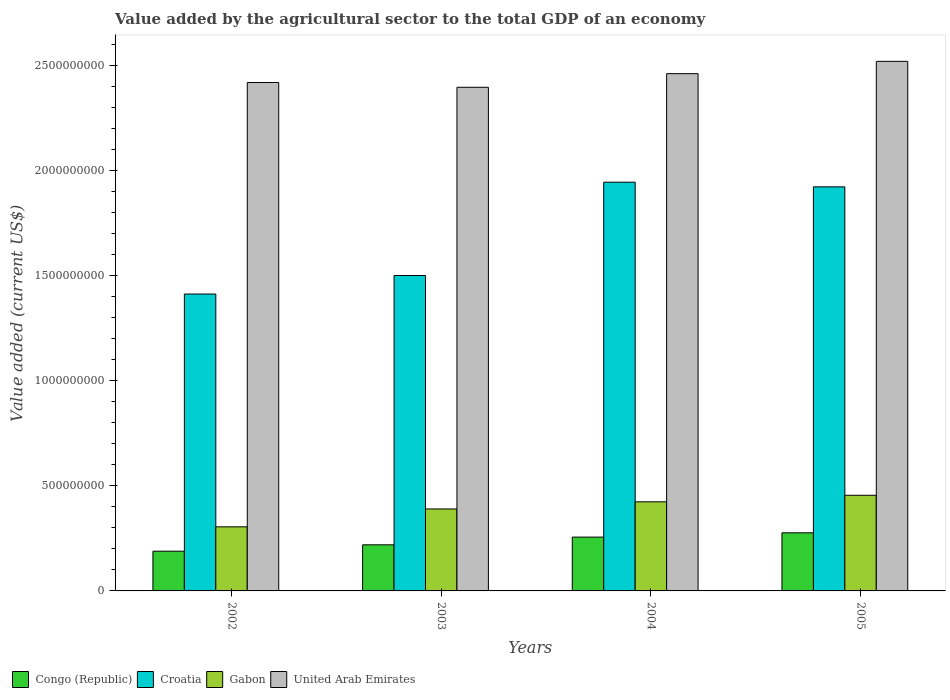Are the number of bars on each tick of the X-axis equal?
Provide a short and direct response. Yes. How many bars are there on the 3rd tick from the left?
Provide a succinct answer. 4. How many bars are there on the 1st tick from the right?
Make the answer very short. 4. What is the label of the 3rd group of bars from the left?
Ensure brevity in your answer.  2004. What is the value added by the agricultural sector to the total GDP in Croatia in 2003?
Provide a short and direct response. 1.50e+09. Across all years, what is the maximum value added by the agricultural sector to the total GDP in Croatia?
Provide a succinct answer. 1.95e+09. Across all years, what is the minimum value added by the agricultural sector to the total GDP in Croatia?
Offer a terse response. 1.41e+09. What is the total value added by the agricultural sector to the total GDP in Congo (Republic) in the graph?
Give a very brief answer. 9.41e+08. What is the difference between the value added by the agricultural sector to the total GDP in Congo (Republic) in 2002 and that in 2004?
Offer a very short reply. -6.70e+07. What is the difference between the value added by the agricultural sector to the total GDP in Congo (Republic) in 2003 and the value added by the agricultural sector to the total GDP in Croatia in 2002?
Provide a succinct answer. -1.19e+09. What is the average value added by the agricultural sector to the total GDP in United Arab Emirates per year?
Provide a short and direct response. 2.45e+09. In the year 2002, what is the difference between the value added by the agricultural sector to the total GDP in United Arab Emirates and value added by the agricultural sector to the total GDP in Gabon?
Your response must be concise. 2.11e+09. In how many years, is the value added by the agricultural sector to the total GDP in United Arab Emirates greater than 1300000000 US$?
Provide a short and direct response. 4. What is the ratio of the value added by the agricultural sector to the total GDP in Congo (Republic) in 2003 to that in 2005?
Your answer should be compact. 0.79. Is the value added by the agricultural sector to the total GDP in United Arab Emirates in 2002 less than that in 2004?
Provide a succinct answer. Yes. What is the difference between the highest and the second highest value added by the agricultural sector to the total GDP in Gabon?
Provide a succinct answer. 3.11e+07. What is the difference between the highest and the lowest value added by the agricultural sector to the total GDP in Gabon?
Provide a succinct answer. 1.50e+08. In how many years, is the value added by the agricultural sector to the total GDP in United Arab Emirates greater than the average value added by the agricultural sector to the total GDP in United Arab Emirates taken over all years?
Give a very brief answer. 2. What does the 2nd bar from the left in 2005 represents?
Give a very brief answer. Croatia. What does the 3rd bar from the right in 2004 represents?
Keep it short and to the point. Croatia. Are all the bars in the graph horizontal?
Offer a terse response. No. What is the difference between two consecutive major ticks on the Y-axis?
Your answer should be very brief. 5.00e+08. Does the graph contain any zero values?
Provide a succinct answer. No. How many legend labels are there?
Give a very brief answer. 4. What is the title of the graph?
Offer a terse response. Value added by the agricultural sector to the total GDP of an economy. Does "Palau" appear as one of the legend labels in the graph?
Offer a very short reply. No. What is the label or title of the Y-axis?
Provide a succinct answer. Value added (current US$). What is the Value added (current US$) in Congo (Republic) in 2002?
Ensure brevity in your answer.  1.89e+08. What is the Value added (current US$) of Croatia in 2002?
Make the answer very short. 1.41e+09. What is the Value added (current US$) of Gabon in 2002?
Your answer should be compact. 3.05e+08. What is the Value added (current US$) of United Arab Emirates in 2002?
Your answer should be compact. 2.42e+09. What is the Value added (current US$) in Congo (Republic) in 2003?
Your answer should be compact. 2.19e+08. What is the Value added (current US$) in Croatia in 2003?
Make the answer very short. 1.50e+09. What is the Value added (current US$) of Gabon in 2003?
Your answer should be very brief. 3.90e+08. What is the Value added (current US$) in United Arab Emirates in 2003?
Provide a succinct answer. 2.40e+09. What is the Value added (current US$) in Congo (Republic) in 2004?
Your answer should be very brief. 2.56e+08. What is the Value added (current US$) of Croatia in 2004?
Give a very brief answer. 1.95e+09. What is the Value added (current US$) in Gabon in 2004?
Offer a terse response. 4.24e+08. What is the Value added (current US$) in United Arab Emirates in 2004?
Provide a short and direct response. 2.46e+09. What is the Value added (current US$) of Congo (Republic) in 2005?
Offer a terse response. 2.77e+08. What is the Value added (current US$) in Croatia in 2005?
Your response must be concise. 1.92e+09. What is the Value added (current US$) in Gabon in 2005?
Your response must be concise. 4.55e+08. What is the Value added (current US$) of United Arab Emirates in 2005?
Offer a terse response. 2.52e+09. Across all years, what is the maximum Value added (current US$) in Congo (Republic)?
Ensure brevity in your answer.  2.77e+08. Across all years, what is the maximum Value added (current US$) in Croatia?
Make the answer very short. 1.95e+09. Across all years, what is the maximum Value added (current US$) of Gabon?
Offer a terse response. 4.55e+08. Across all years, what is the maximum Value added (current US$) of United Arab Emirates?
Your response must be concise. 2.52e+09. Across all years, what is the minimum Value added (current US$) in Congo (Republic)?
Your answer should be very brief. 1.89e+08. Across all years, what is the minimum Value added (current US$) in Croatia?
Offer a terse response. 1.41e+09. Across all years, what is the minimum Value added (current US$) of Gabon?
Give a very brief answer. 3.05e+08. Across all years, what is the minimum Value added (current US$) of United Arab Emirates?
Offer a terse response. 2.40e+09. What is the total Value added (current US$) in Congo (Republic) in the graph?
Provide a succinct answer. 9.41e+08. What is the total Value added (current US$) of Croatia in the graph?
Provide a short and direct response. 6.78e+09. What is the total Value added (current US$) of Gabon in the graph?
Ensure brevity in your answer.  1.57e+09. What is the total Value added (current US$) of United Arab Emirates in the graph?
Keep it short and to the point. 9.80e+09. What is the difference between the Value added (current US$) of Congo (Republic) in 2002 and that in 2003?
Offer a very short reply. -3.03e+07. What is the difference between the Value added (current US$) in Croatia in 2002 and that in 2003?
Your answer should be compact. -8.82e+07. What is the difference between the Value added (current US$) in Gabon in 2002 and that in 2003?
Offer a very short reply. -8.51e+07. What is the difference between the Value added (current US$) in United Arab Emirates in 2002 and that in 2003?
Make the answer very short. 2.26e+07. What is the difference between the Value added (current US$) in Congo (Republic) in 2002 and that in 2004?
Make the answer very short. -6.70e+07. What is the difference between the Value added (current US$) of Croatia in 2002 and that in 2004?
Your response must be concise. -5.32e+08. What is the difference between the Value added (current US$) in Gabon in 2002 and that in 2004?
Provide a succinct answer. -1.19e+08. What is the difference between the Value added (current US$) in United Arab Emirates in 2002 and that in 2004?
Offer a terse response. -4.22e+07. What is the difference between the Value added (current US$) of Congo (Republic) in 2002 and that in 2005?
Make the answer very short. -8.75e+07. What is the difference between the Value added (current US$) in Croatia in 2002 and that in 2005?
Your answer should be very brief. -5.10e+08. What is the difference between the Value added (current US$) in Gabon in 2002 and that in 2005?
Offer a very short reply. -1.50e+08. What is the difference between the Value added (current US$) of United Arab Emirates in 2002 and that in 2005?
Keep it short and to the point. -1.01e+08. What is the difference between the Value added (current US$) in Congo (Republic) in 2003 and that in 2004?
Ensure brevity in your answer.  -3.67e+07. What is the difference between the Value added (current US$) of Croatia in 2003 and that in 2004?
Keep it short and to the point. -4.44e+08. What is the difference between the Value added (current US$) of Gabon in 2003 and that in 2004?
Give a very brief answer. -3.40e+07. What is the difference between the Value added (current US$) in United Arab Emirates in 2003 and that in 2004?
Your response must be concise. -6.48e+07. What is the difference between the Value added (current US$) of Congo (Republic) in 2003 and that in 2005?
Your answer should be very brief. -5.72e+07. What is the difference between the Value added (current US$) in Croatia in 2003 and that in 2005?
Make the answer very short. -4.22e+08. What is the difference between the Value added (current US$) of Gabon in 2003 and that in 2005?
Your answer should be compact. -6.51e+07. What is the difference between the Value added (current US$) in United Arab Emirates in 2003 and that in 2005?
Provide a succinct answer. -1.23e+08. What is the difference between the Value added (current US$) in Congo (Republic) in 2004 and that in 2005?
Provide a short and direct response. -2.05e+07. What is the difference between the Value added (current US$) of Croatia in 2004 and that in 2005?
Offer a very short reply. 2.22e+07. What is the difference between the Value added (current US$) in Gabon in 2004 and that in 2005?
Provide a succinct answer. -3.11e+07. What is the difference between the Value added (current US$) in United Arab Emirates in 2004 and that in 2005?
Keep it short and to the point. -5.85e+07. What is the difference between the Value added (current US$) in Congo (Republic) in 2002 and the Value added (current US$) in Croatia in 2003?
Offer a terse response. -1.31e+09. What is the difference between the Value added (current US$) of Congo (Republic) in 2002 and the Value added (current US$) of Gabon in 2003?
Your answer should be very brief. -2.01e+08. What is the difference between the Value added (current US$) in Congo (Republic) in 2002 and the Value added (current US$) in United Arab Emirates in 2003?
Your response must be concise. -2.21e+09. What is the difference between the Value added (current US$) of Croatia in 2002 and the Value added (current US$) of Gabon in 2003?
Offer a terse response. 1.02e+09. What is the difference between the Value added (current US$) in Croatia in 2002 and the Value added (current US$) in United Arab Emirates in 2003?
Provide a succinct answer. -9.84e+08. What is the difference between the Value added (current US$) in Gabon in 2002 and the Value added (current US$) in United Arab Emirates in 2003?
Make the answer very short. -2.09e+09. What is the difference between the Value added (current US$) in Congo (Republic) in 2002 and the Value added (current US$) in Croatia in 2004?
Provide a short and direct response. -1.76e+09. What is the difference between the Value added (current US$) of Congo (Republic) in 2002 and the Value added (current US$) of Gabon in 2004?
Provide a succinct answer. -2.35e+08. What is the difference between the Value added (current US$) of Congo (Republic) in 2002 and the Value added (current US$) of United Arab Emirates in 2004?
Offer a very short reply. -2.27e+09. What is the difference between the Value added (current US$) in Croatia in 2002 and the Value added (current US$) in Gabon in 2004?
Keep it short and to the point. 9.89e+08. What is the difference between the Value added (current US$) in Croatia in 2002 and the Value added (current US$) in United Arab Emirates in 2004?
Your answer should be compact. -1.05e+09. What is the difference between the Value added (current US$) in Gabon in 2002 and the Value added (current US$) in United Arab Emirates in 2004?
Provide a short and direct response. -2.16e+09. What is the difference between the Value added (current US$) of Congo (Republic) in 2002 and the Value added (current US$) of Croatia in 2005?
Your answer should be very brief. -1.73e+09. What is the difference between the Value added (current US$) in Congo (Republic) in 2002 and the Value added (current US$) in Gabon in 2005?
Your answer should be compact. -2.66e+08. What is the difference between the Value added (current US$) in Congo (Republic) in 2002 and the Value added (current US$) in United Arab Emirates in 2005?
Make the answer very short. -2.33e+09. What is the difference between the Value added (current US$) of Croatia in 2002 and the Value added (current US$) of Gabon in 2005?
Your answer should be very brief. 9.58e+08. What is the difference between the Value added (current US$) of Croatia in 2002 and the Value added (current US$) of United Arab Emirates in 2005?
Your answer should be compact. -1.11e+09. What is the difference between the Value added (current US$) of Gabon in 2002 and the Value added (current US$) of United Arab Emirates in 2005?
Provide a short and direct response. -2.22e+09. What is the difference between the Value added (current US$) of Congo (Republic) in 2003 and the Value added (current US$) of Croatia in 2004?
Ensure brevity in your answer.  -1.73e+09. What is the difference between the Value added (current US$) in Congo (Republic) in 2003 and the Value added (current US$) in Gabon in 2004?
Give a very brief answer. -2.05e+08. What is the difference between the Value added (current US$) in Congo (Republic) in 2003 and the Value added (current US$) in United Arab Emirates in 2004?
Your answer should be very brief. -2.24e+09. What is the difference between the Value added (current US$) of Croatia in 2003 and the Value added (current US$) of Gabon in 2004?
Your response must be concise. 1.08e+09. What is the difference between the Value added (current US$) in Croatia in 2003 and the Value added (current US$) in United Arab Emirates in 2004?
Provide a succinct answer. -9.61e+08. What is the difference between the Value added (current US$) in Gabon in 2003 and the Value added (current US$) in United Arab Emirates in 2004?
Offer a very short reply. -2.07e+09. What is the difference between the Value added (current US$) in Congo (Republic) in 2003 and the Value added (current US$) in Croatia in 2005?
Your response must be concise. -1.70e+09. What is the difference between the Value added (current US$) in Congo (Republic) in 2003 and the Value added (current US$) in Gabon in 2005?
Keep it short and to the point. -2.36e+08. What is the difference between the Value added (current US$) of Congo (Republic) in 2003 and the Value added (current US$) of United Arab Emirates in 2005?
Offer a terse response. -2.30e+09. What is the difference between the Value added (current US$) in Croatia in 2003 and the Value added (current US$) in Gabon in 2005?
Your response must be concise. 1.05e+09. What is the difference between the Value added (current US$) of Croatia in 2003 and the Value added (current US$) of United Arab Emirates in 2005?
Ensure brevity in your answer.  -1.02e+09. What is the difference between the Value added (current US$) of Gabon in 2003 and the Value added (current US$) of United Arab Emirates in 2005?
Your answer should be compact. -2.13e+09. What is the difference between the Value added (current US$) of Congo (Republic) in 2004 and the Value added (current US$) of Croatia in 2005?
Your answer should be very brief. -1.67e+09. What is the difference between the Value added (current US$) of Congo (Republic) in 2004 and the Value added (current US$) of Gabon in 2005?
Your answer should be compact. -1.99e+08. What is the difference between the Value added (current US$) of Congo (Republic) in 2004 and the Value added (current US$) of United Arab Emirates in 2005?
Your answer should be compact. -2.26e+09. What is the difference between the Value added (current US$) in Croatia in 2004 and the Value added (current US$) in Gabon in 2005?
Make the answer very short. 1.49e+09. What is the difference between the Value added (current US$) in Croatia in 2004 and the Value added (current US$) in United Arab Emirates in 2005?
Ensure brevity in your answer.  -5.75e+08. What is the difference between the Value added (current US$) of Gabon in 2004 and the Value added (current US$) of United Arab Emirates in 2005?
Provide a short and direct response. -2.10e+09. What is the average Value added (current US$) in Congo (Republic) per year?
Ensure brevity in your answer.  2.35e+08. What is the average Value added (current US$) in Croatia per year?
Ensure brevity in your answer.  1.70e+09. What is the average Value added (current US$) in Gabon per year?
Your answer should be very brief. 3.94e+08. What is the average Value added (current US$) of United Arab Emirates per year?
Ensure brevity in your answer.  2.45e+09. In the year 2002, what is the difference between the Value added (current US$) in Congo (Republic) and Value added (current US$) in Croatia?
Provide a succinct answer. -1.22e+09. In the year 2002, what is the difference between the Value added (current US$) in Congo (Republic) and Value added (current US$) in Gabon?
Ensure brevity in your answer.  -1.16e+08. In the year 2002, what is the difference between the Value added (current US$) of Congo (Republic) and Value added (current US$) of United Arab Emirates?
Your answer should be compact. -2.23e+09. In the year 2002, what is the difference between the Value added (current US$) in Croatia and Value added (current US$) in Gabon?
Ensure brevity in your answer.  1.11e+09. In the year 2002, what is the difference between the Value added (current US$) of Croatia and Value added (current US$) of United Arab Emirates?
Your answer should be very brief. -1.01e+09. In the year 2002, what is the difference between the Value added (current US$) in Gabon and Value added (current US$) in United Arab Emirates?
Provide a succinct answer. -2.11e+09. In the year 2003, what is the difference between the Value added (current US$) in Congo (Republic) and Value added (current US$) in Croatia?
Keep it short and to the point. -1.28e+09. In the year 2003, what is the difference between the Value added (current US$) in Congo (Republic) and Value added (current US$) in Gabon?
Keep it short and to the point. -1.71e+08. In the year 2003, what is the difference between the Value added (current US$) in Congo (Republic) and Value added (current US$) in United Arab Emirates?
Offer a very short reply. -2.18e+09. In the year 2003, what is the difference between the Value added (current US$) of Croatia and Value added (current US$) of Gabon?
Your response must be concise. 1.11e+09. In the year 2003, what is the difference between the Value added (current US$) of Croatia and Value added (current US$) of United Arab Emirates?
Ensure brevity in your answer.  -8.96e+08. In the year 2003, what is the difference between the Value added (current US$) in Gabon and Value added (current US$) in United Arab Emirates?
Make the answer very short. -2.01e+09. In the year 2004, what is the difference between the Value added (current US$) of Congo (Republic) and Value added (current US$) of Croatia?
Offer a very short reply. -1.69e+09. In the year 2004, what is the difference between the Value added (current US$) in Congo (Republic) and Value added (current US$) in Gabon?
Your response must be concise. -1.68e+08. In the year 2004, what is the difference between the Value added (current US$) of Congo (Republic) and Value added (current US$) of United Arab Emirates?
Offer a terse response. -2.21e+09. In the year 2004, what is the difference between the Value added (current US$) in Croatia and Value added (current US$) in Gabon?
Ensure brevity in your answer.  1.52e+09. In the year 2004, what is the difference between the Value added (current US$) of Croatia and Value added (current US$) of United Arab Emirates?
Provide a short and direct response. -5.17e+08. In the year 2004, what is the difference between the Value added (current US$) in Gabon and Value added (current US$) in United Arab Emirates?
Your answer should be compact. -2.04e+09. In the year 2005, what is the difference between the Value added (current US$) of Congo (Republic) and Value added (current US$) of Croatia?
Ensure brevity in your answer.  -1.65e+09. In the year 2005, what is the difference between the Value added (current US$) of Congo (Republic) and Value added (current US$) of Gabon?
Ensure brevity in your answer.  -1.79e+08. In the year 2005, what is the difference between the Value added (current US$) of Congo (Republic) and Value added (current US$) of United Arab Emirates?
Your answer should be very brief. -2.24e+09. In the year 2005, what is the difference between the Value added (current US$) of Croatia and Value added (current US$) of Gabon?
Your response must be concise. 1.47e+09. In the year 2005, what is the difference between the Value added (current US$) in Croatia and Value added (current US$) in United Arab Emirates?
Give a very brief answer. -5.97e+08. In the year 2005, what is the difference between the Value added (current US$) in Gabon and Value added (current US$) in United Arab Emirates?
Provide a succinct answer. -2.07e+09. What is the ratio of the Value added (current US$) of Congo (Republic) in 2002 to that in 2003?
Your answer should be very brief. 0.86. What is the ratio of the Value added (current US$) of Croatia in 2002 to that in 2003?
Give a very brief answer. 0.94. What is the ratio of the Value added (current US$) in Gabon in 2002 to that in 2003?
Your answer should be very brief. 0.78. What is the ratio of the Value added (current US$) in United Arab Emirates in 2002 to that in 2003?
Offer a very short reply. 1.01. What is the ratio of the Value added (current US$) of Congo (Republic) in 2002 to that in 2004?
Offer a very short reply. 0.74. What is the ratio of the Value added (current US$) of Croatia in 2002 to that in 2004?
Offer a terse response. 0.73. What is the ratio of the Value added (current US$) of Gabon in 2002 to that in 2004?
Your answer should be compact. 0.72. What is the ratio of the Value added (current US$) of United Arab Emirates in 2002 to that in 2004?
Ensure brevity in your answer.  0.98. What is the ratio of the Value added (current US$) in Congo (Republic) in 2002 to that in 2005?
Provide a short and direct response. 0.68. What is the ratio of the Value added (current US$) in Croatia in 2002 to that in 2005?
Give a very brief answer. 0.73. What is the ratio of the Value added (current US$) of Gabon in 2002 to that in 2005?
Offer a terse response. 0.67. What is the ratio of the Value added (current US$) of Congo (Republic) in 2003 to that in 2004?
Provide a succinct answer. 0.86. What is the ratio of the Value added (current US$) of Croatia in 2003 to that in 2004?
Make the answer very short. 0.77. What is the ratio of the Value added (current US$) of Gabon in 2003 to that in 2004?
Your response must be concise. 0.92. What is the ratio of the Value added (current US$) of United Arab Emirates in 2003 to that in 2004?
Offer a terse response. 0.97. What is the ratio of the Value added (current US$) of Congo (Republic) in 2003 to that in 2005?
Your response must be concise. 0.79. What is the ratio of the Value added (current US$) in Croatia in 2003 to that in 2005?
Your answer should be compact. 0.78. What is the ratio of the Value added (current US$) of Gabon in 2003 to that in 2005?
Your answer should be very brief. 0.86. What is the ratio of the Value added (current US$) of United Arab Emirates in 2003 to that in 2005?
Your answer should be compact. 0.95. What is the ratio of the Value added (current US$) in Congo (Republic) in 2004 to that in 2005?
Make the answer very short. 0.93. What is the ratio of the Value added (current US$) of Croatia in 2004 to that in 2005?
Offer a terse response. 1.01. What is the ratio of the Value added (current US$) in Gabon in 2004 to that in 2005?
Offer a very short reply. 0.93. What is the ratio of the Value added (current US$) of United Arab Emirates in 2004 to that in 2005?
Offer a very short reply. 0.98. What is the difference between the highest and the second highest Value added (current US$) of Congo (Republic)?
Provide a succinct answer. 2.05e+07. What is the difference between the highest and the second highest Value added (current US$) of Croatia?
Your answer should be compact. 2.22e+07. What is the difference between the highest and the second highest Value added (current US$) of Gabon?
Provide a succinct answer. 3.11e+07. What is the difference between the highest and the second highest Value added (current US$) of United Arab Emirates?
Ensure brevity in your answer.  5.85e+07. What is the difference between the highest and the lowest Value added (current US$) in Congo (Republic)?
Give a very brief answer. 8.75e+07. What is the difference between the highest and the lowest Value added (current US$) in Croatia?
Provide a short and direct response. 5.32e+08. What is the difference between the highest and the lowest Value added (current US$) of Gabon?
Make the answer very short. 1.50e+08. What is the difference between the highest and the lowest Value added (current US$) in United Arab Emirates?
Give a very brief answer. 1.23e+08. 